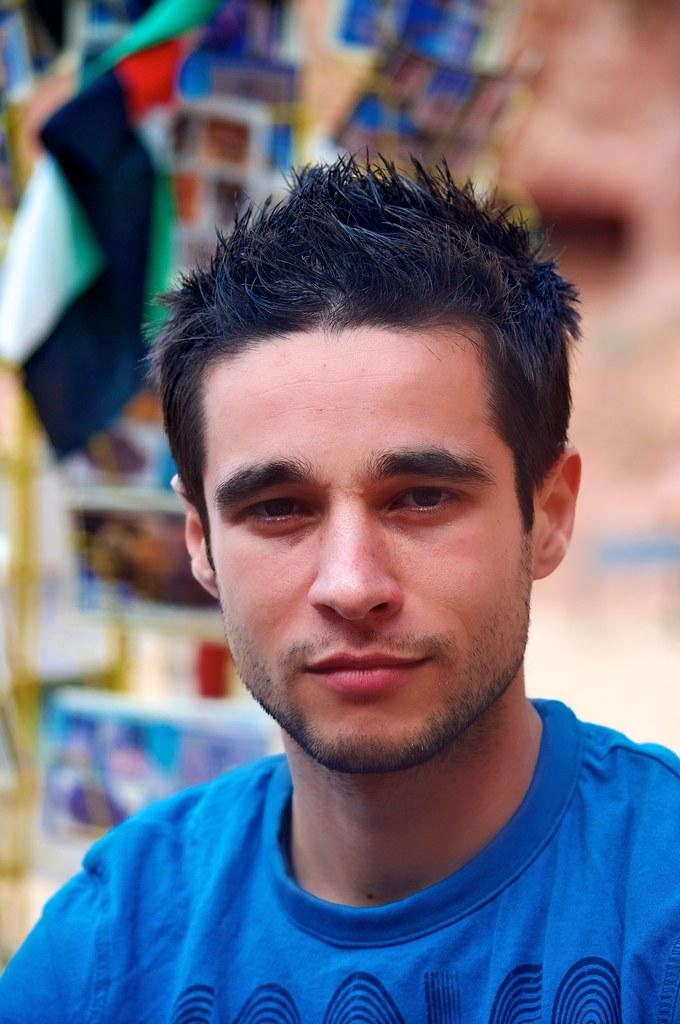Who is present in the image? There is a man in the image. What is the man wearing? The man is wearing a blue t-shirt. What can be seen in the background of the image? There is a flag in the background of the image. How would you describe the background of the background of the image? The background of the image is blurred. How does the earthquake affect the motion of the man in the image? There is no earthquake present in the image, so its effect on the man's motion cannot be determined. 